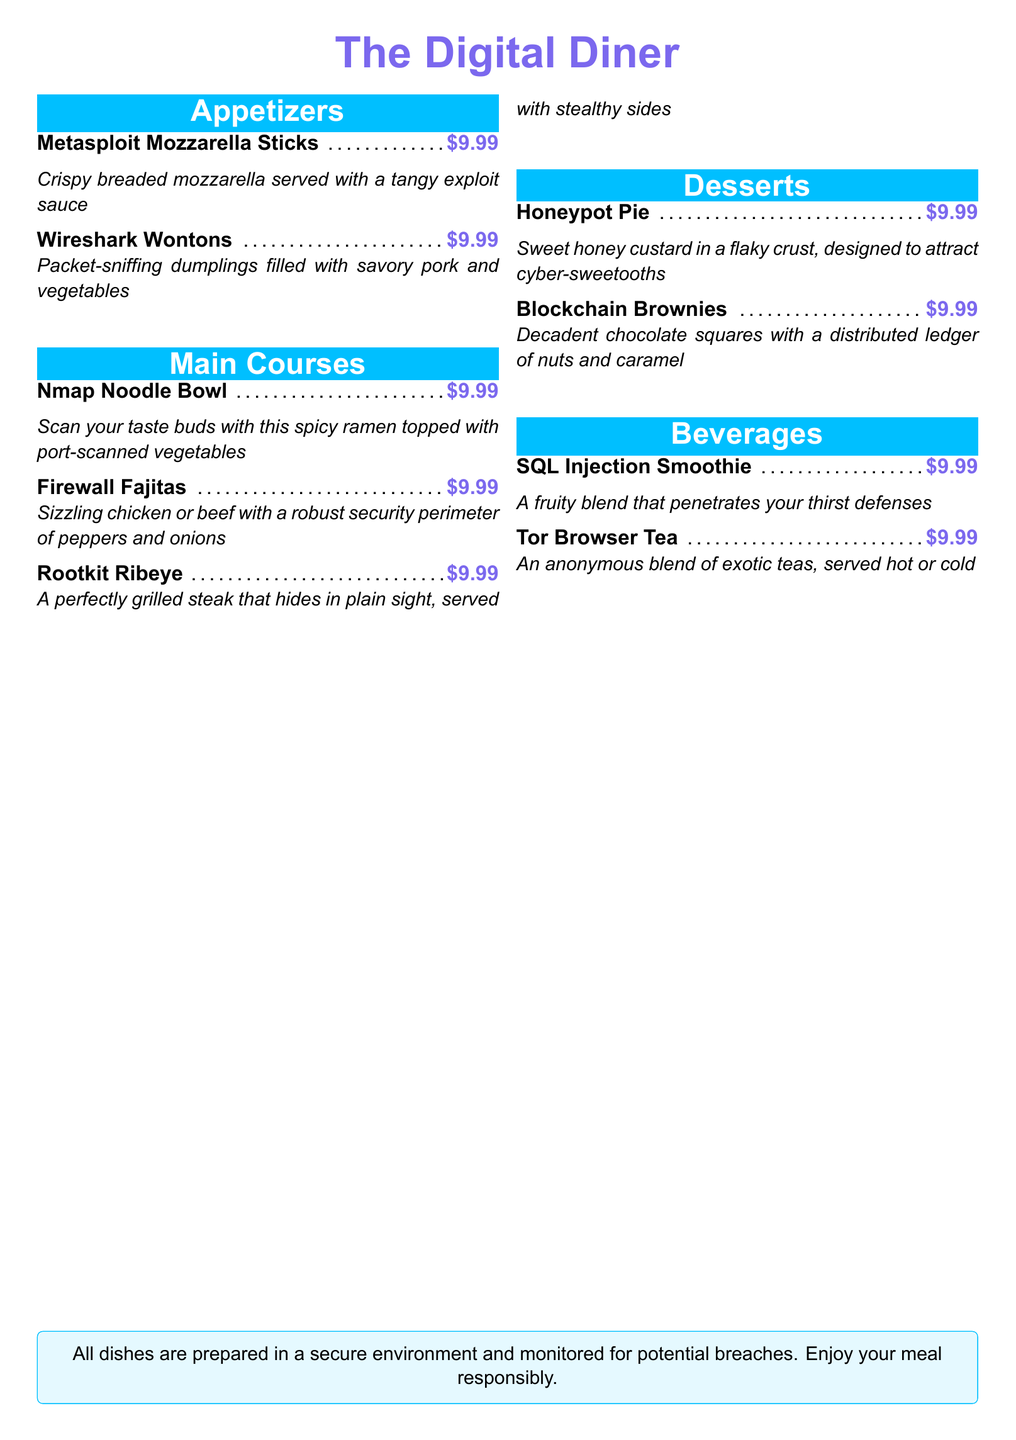What is the name of the dessert that attracts cyber-sweetooths? The dessert designed to attract cyber-sweetooths is called Honeypot Pie.
Answer: Honeypot Pie How much do the Wireshark Wontons cost? The cost of Wireshark Wontons is indicated next to the dish name, which is $9.99.
Answer: $9.99 What main course includes port-scanned vegetables? The main course featuring port-scanned vegetables is Nmap Noodle Bowl.
Answer: Nmap Noodle Bowl How many appetizers are listed in the menu? By counting the appetizers in the document, there are two listed: Metasploit Mozzarella Sticks and Wireshark Wontons.
Answer: 2 Which beverage is an anonymous blend of exotic teas? The drink that is an anonymous blend of exotic teas is called Tor Browser Tea.
Answer: Tor Browser Tea What type of meat can be found in Firewall Fajitas? The types of meat available in Firewall Fajitas are chicken or beef.
Answer: Chicken or beef What is a key ingredient in Blockchain Brownies? One of the key ingredients in Blockchain Brownies is nuts.
Answer: Nuts Which dish serves a perfectly grilled steak? The dish that serves a perfectly grilled steak is Rootkit Ribeye.
Answer: Rootkit Ribeye What is the theme of the restaurant? The theme involves cybersecurity and hacking, evident from the dish names.
Answer: Cybersecurity 